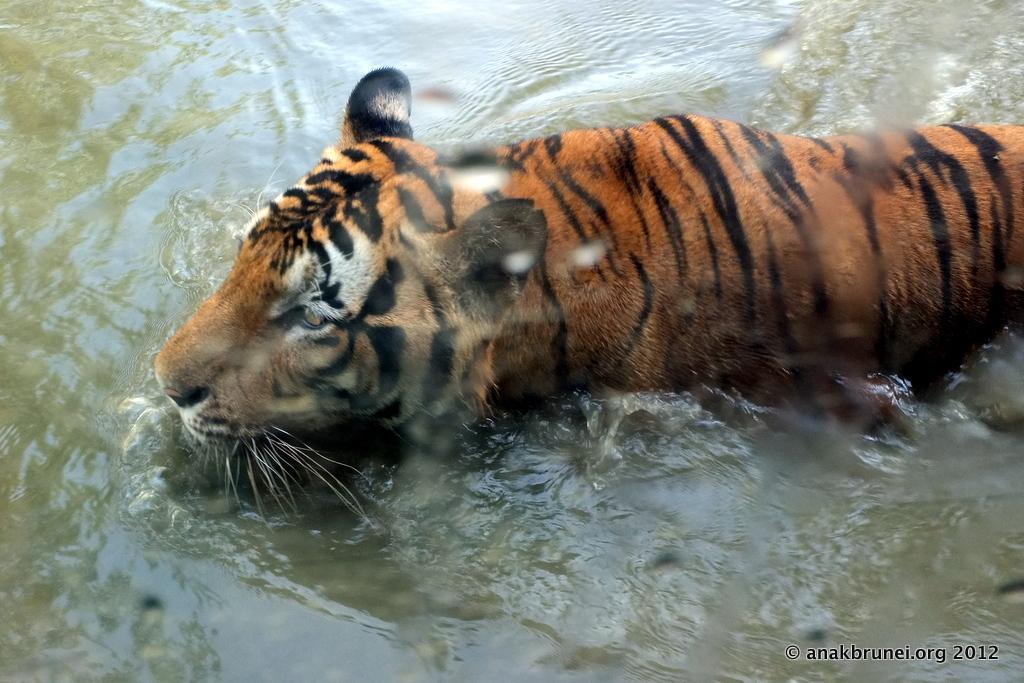Describe this image in one or two sentences. This image consists of a tiger walking in the water. At the bottom, there is water. 